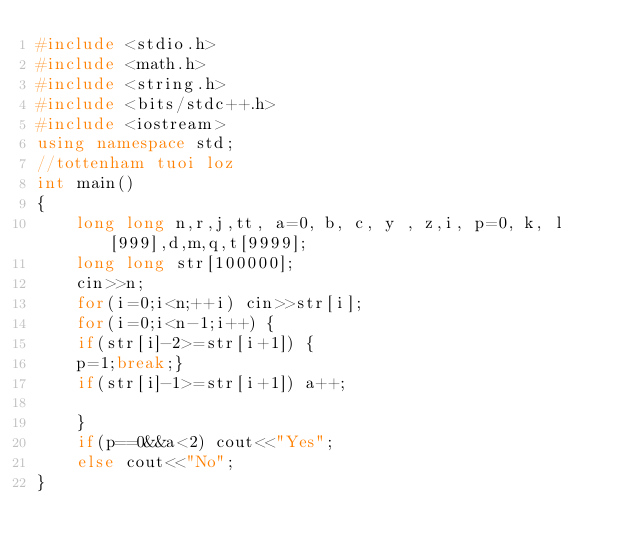Convert code to text. <code><loc_0><loc_0><loc_500><loc_500><_C++_>#include <stdio.h>
#include <math.h>
#include <string.h>
#include <bits/stdc++.h>
#include <iostream>
using namespace std;
//tottenham tuoi loz 
int main()
{
	long long n,r,j,tt, a=0, b, c, y , z,i, p=0, k, l[999],d,m,q,t[9999];
	long long str[100000];
	cin>>n;
	for(i=0;i<n;++i) cin>>str[i];
	for(i=0;i<n-1;i++) {
	if(str[i]-2>=str[i+1]) {
	p=1;break;}
	if(str[i]-1>=str[i+1]) a++;
	
	}
	if(p==0&&a<2) cout<<"Yes";
	else cout<<"No";
}</code> 